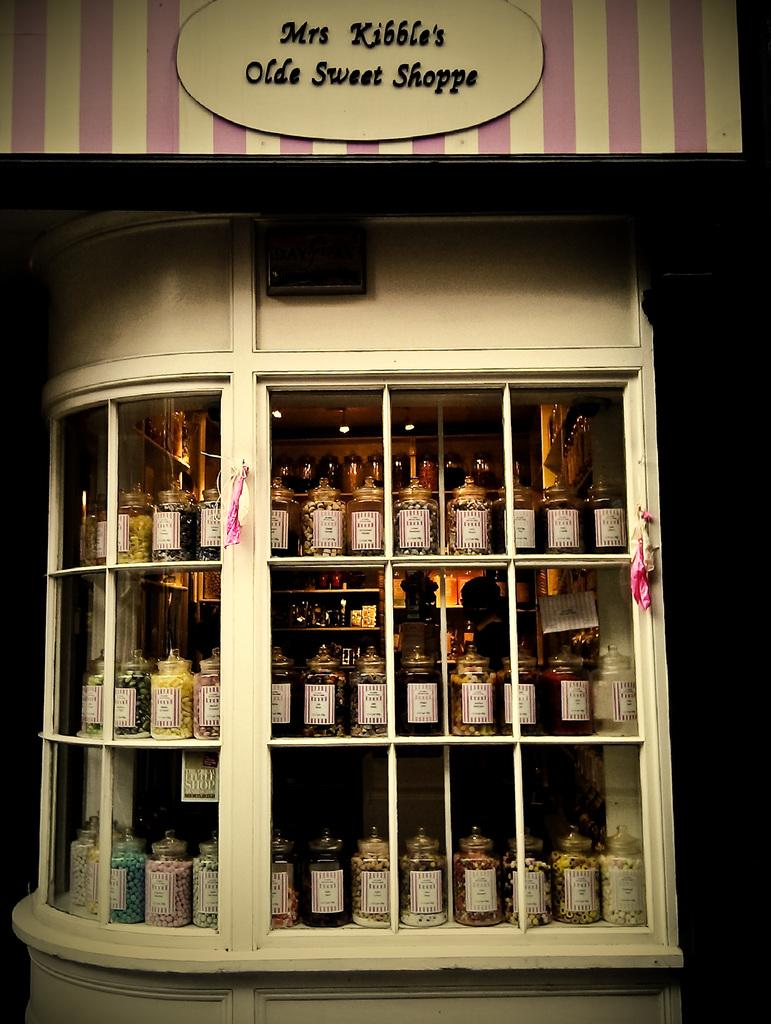Provide a one-sentence caption for the provided image. Several jars of candies sit in the window on Mrs Kibble's Olde Sweet Shoppe. 